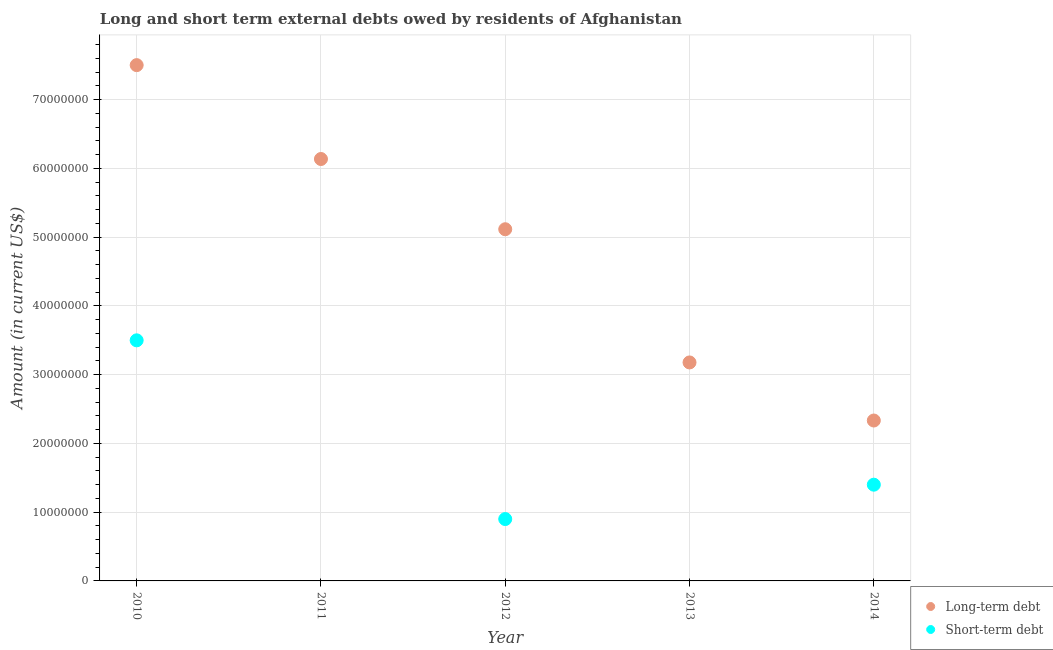How many different coloured dotlines are there?
Keep it short and to the point. 2. What is the long-term debts owed by residents in 2012?
Your answer should be compact. 5.12e+07. Across all years, what is the maximum short-term debts owed by residents?
Ensure brevity in your answer.  3.50e+07. In which year was the short-term debts owed by residents maximum?
Give a very brief answer. 2010. What is the total long-term debts owed by residents in the graph?
Your answer should be very brief. 2.43e+08. What is the difference between the short-term debts owed by residents in 2010 and that in 2012?
Offer a terse response. 2.60e+07. What is the difference between the long-term debts owed by residents in 2011 and the short-term debts owed by residents in 2010?
Offer a terse response. 2.64e+07. What is the average long-term debts owed by residents per year?
Keep it short and to the point. 4.85e+07. In the year 2010, what is the difference between the long-term debts owed by residents and short-term debts owed by residents?
Ensure brevity in your answer.  4.00e+07. Is the short-term debts owed by residents in 2010 less than that in 2012?
Offer a terse response. No. Is the difference between the long-term debts owed by residents in 2012 and 2014 greater than the difference between the short-term debts owed by residents in 2012 and 2014?
Your answer should be compact. Yes. What is the difference between the highest and the second highest short-term debts owed by residents?
Your answer should be very brief. 2.10e+07. What is the difference between the highest and the lowest short-term debts owed by residents?
Offer a very short reply. 3.50e+07. Does the long-term debts owed by residents monotonically increase over the years?
Make the answer very short. No. Is the long-term debts owed by residents strictly less than the short-term debts owed by residents over the years?
Your answer should be compact. No. What is the difference between two consecutive major ticks on the Y-axis?
Make the answer very short. 1.00e+07. Where does the legend appear in the graph?
Provide a short and direct response. Bottom right. What is the title of the graph?
Keep it short and to the point. Long and short term external debts owed by residents of Afghanistan. Does "Primary school" appear as one of the legend labels in the graph?
Your response must be concise. No. What is the label or title of the X-axis?
Make the answer very short. Year. What is the label or title of the Y-axis?
Your response must be concise. Amount (in current US$). What is the Amount (in current US$) of Long-term debt in 2010?
Your response must be concise. 7.50e+07. What is the Amount (in current US$) of Short-term debt in 2010?
Provide a short and direct response. 3.50e+07. What is the Amount (in current US$) of Long-term debt in 2011?
Provide a short and direct response. 6.14e+07. What is the Amount (in current US$) in Short-term debt in 2011?
Keep it short and to the point. 0. What is the Amount (in current US$) in Long-term debt in 2012?
Give a very brief answer. 5.12e+07. What is the Amount (in current US$) of Short-term debt in 2012?
Give a very brief answer. 9.00e+06. What is the Amount (in current US$) of Long-term debt in 2013?
Provide a succinct answer. 3.18e+07. What is the Amount (in current US$) of Short-term debt in 2013?
Make the answer very short. 0. What is the Amount (in current US$) of Long-term debt in 2014?
Offer a very short reply. 2.33e+07. What is the Amount (in current US$) of Short-term debt in 2014?
Ensure brevity in your answer.  1.40e+07. Across all years, what is the maximum Amount (in current US$) in Long-term debt?
Ensure brevity in your answer.  7.50e+07. Across all years, what is the maximum Amount (in current US$) of Short-term debt?
Ensure brevity in your answer.  3.50e+07. Across all years, what is the minimum Amount (in current US$) in Long-term debt?
Give a very brief answer. 2.33e+07. What is the total Amount (in current US$) of Long-term debt in the graph?
Your answer should be very brief. 2.43e+08. What is the total Amount (in current US$) of Short-term debt in the graph?
Keep it short and to the point. 5.80e+07. What is the difference between the Amount (in current US$) of Long-term debt in 2010 and that in 2011?
Your answer should be very brief. 1.37e+07. What is the difference between the Amount (in current US$) of Long-term debt in 2010 and that in 2012?
Your response must be concise. 2.39e+07. What is the difference between the Amount (in current US$) in Short-term debt in 2010 and that in 2012?
Offer a terse response. 2.60e+07. What is the difference between the Amount (in current US$) in Long-term debt in 2010 and that in 2013?
Your answer should be compact. 4.33e+07. What is the difference between the Amount (in current US$) of Long-term debt in 2010 and that in 2014?
Your answer should be very brief. 5.17e+07. What is the difference between the Amount (in current US$) of Short-term debt in 2010 and that in 2014?
Offer a terse response. 2.10e+07. What is the difference between the Amount (in current US$) of Long-term debt in 2011 and that in 2012?
Provide a short and direct response. 1.02e+07. What is the difference between the Amount (in current US$) of Long-term debt in 2011 and that in 2013?
Provide a succinct answer. 2.96e+07. What is the difference between the Amount (in current US$) in Long-term debt in 2011 and that in 2014?
Provide a short and direct response. 3.80e+07. What is the difference between the Amount (in current US$) in Long-term debt in 2012 and that in 2013?
Make the answer very short. 1.94e+07. What is the difference between the Amount (in current US$) in Long-term debt in 2012 and that in 2014?
Provide a short and direct response. 2.78e+07. What is the difference between the Amount (in current US$) in Short-term debt in 2012 and that in 2014?
Provide a succinct answer. -5.00e+06. What is the difference between the Amount (in current US$) of Long-term debt in 2013 and that in 2014?
Offer a terse response. 8.45e+06. What is the difference between the Amount (in current US$) of Long-term debt in 2010 and the Amount (in current US$) of Short-term debt in 2012?
Ensure brevity in your answer.  6.60e+07. What is the difference between the Amount (in current US$) in Long-term debt in 2010 and the Amount (in current US$) in Short-term debt in 2014?
Make the answer very short. 6.10e+07. What is the difference between the Amount (in current US$) of Long-term debt in 2011 and the Amount (in current US$) of Short-term debt in 2012?
Your answer should be very brief. 5.24e+07. What is the difference between the Amount (in current US$) of Long-term debt in 2011 and the Amount (in current US$) of Short-term debt in 2014?
Your answer should be compact. 4.74e+07. What is the difference between the Amount (in current US$) in Long-term debt in 2012 and the Amount (in current US$) in Short-term debt in 2014?
Provide a short and direct response. 3.72e+07. What is the difference between the Amount (in current US$) of Long-term debt in 2013 and the Amount (in current US$) of Short-term debt in 2014?
Give a very brief answer. 1.78e+07. What is the average Amount (in current US$) of Long-term debt per year?
Your answer should be very brief. 4.85e+07. What is the average Amount (in current US$) in Short-term debt per year?
Give a very brief answer. 1.16e+07. In the year 2010, what is the difference between the Amount (in current US$) of Long-term debt and Amount (in current US$) of Short-term debt?
Your response must be concise. 4.00e+07. In the year 2012, what is the difference between the Amount (in current US$) in Long-term debt and Amount (in current US$) in Short-term debt?
Keep it short and to the point. 4.22e+07. In the year 2014, what is the difference between the Amount (in current US$) in Long-term debt and Amount (in current US$) in Short-term debt?
Make the answer very short. 9.34e+06. What is the ratio of the Amount (in current US$) in Long-term debt in 2010 to that in 2011?
Your response must be concise. 1.22. What is the ratio of the Amount (in current US$) in Long-term debt in 2010 to that in 2012?
Make the answer very short. 1.47. What is the ratio of the Amount (in current US$) of Short-term debt in 2010 to that in 2012?
Make the answer very short. 3.89. What is the ratio of the Amount (in current US$) of Long-term debt in 2010 to that in 2013?
Offer a terse response. 2.36. What is the ratio of the Amount (in current US$) of Long-term debt in 2010 to that in 2014?
Offer a very short reply. 3.22. What is the ratio of the Amount (in current US$) of Long-term debt in 2011 to that in 2012?
Your answer should be compact. 1.2. What is the ratio of the Amount (in current US$) in Long-term debt in 2011 to that in 2013?
Provide a short and direct response. 1.93. What is the ratio of the Amount (in current US$) of Long-term debt in 2011 to that in 2014?
Your answer should be compact. 2.63. What is the ratio of the Amount (in current US$) of Long-term debt in 2012 to that in 2013?
Offer a very short reply. 1.61. What is the ratio of the Amount (in current US$) of Long-term debt in 2012 to that in 2014?
Offer a very short reply. 2.19. What is the ratio of the Amount (in current US$) of Short-term debt in 2012 to that in 2014?
Give a very brief answer. 0.64. What is the ratio of the Amount (in current US$) in Long-term debt in 2013 to that in 2014?
Give a very brief answer. 1.36. What is the difference between the highest and the second highest Amount (in current US$) in Long-term debt?
Provide a succinct answer. 1.37e+07. What is the difference between the highest and the second highest Amount (in current US$) of Short-term debt?
Keep it short and to the point. 2.10e+07. What is the difference between the highest and the lowest Amount (in current US$) of Long-term debt?
Provide a short and direct response. 5.17e+07. What is the difference between the highest and the lowest Amount (in current US$) of Short-term debt?
Your response must be concise. 3.50e+07. 